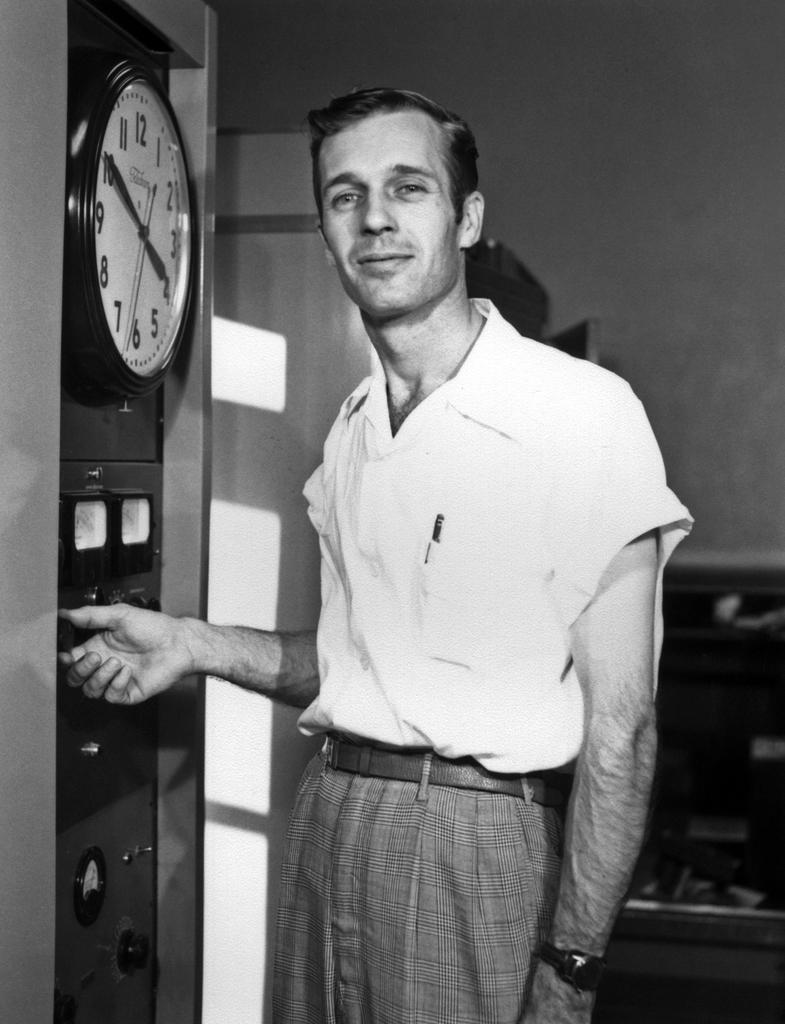Provide a one-sentence caption for the provided image. A man wearing a white shirt stands next to a clock with a time of 4:50 showing on it. 